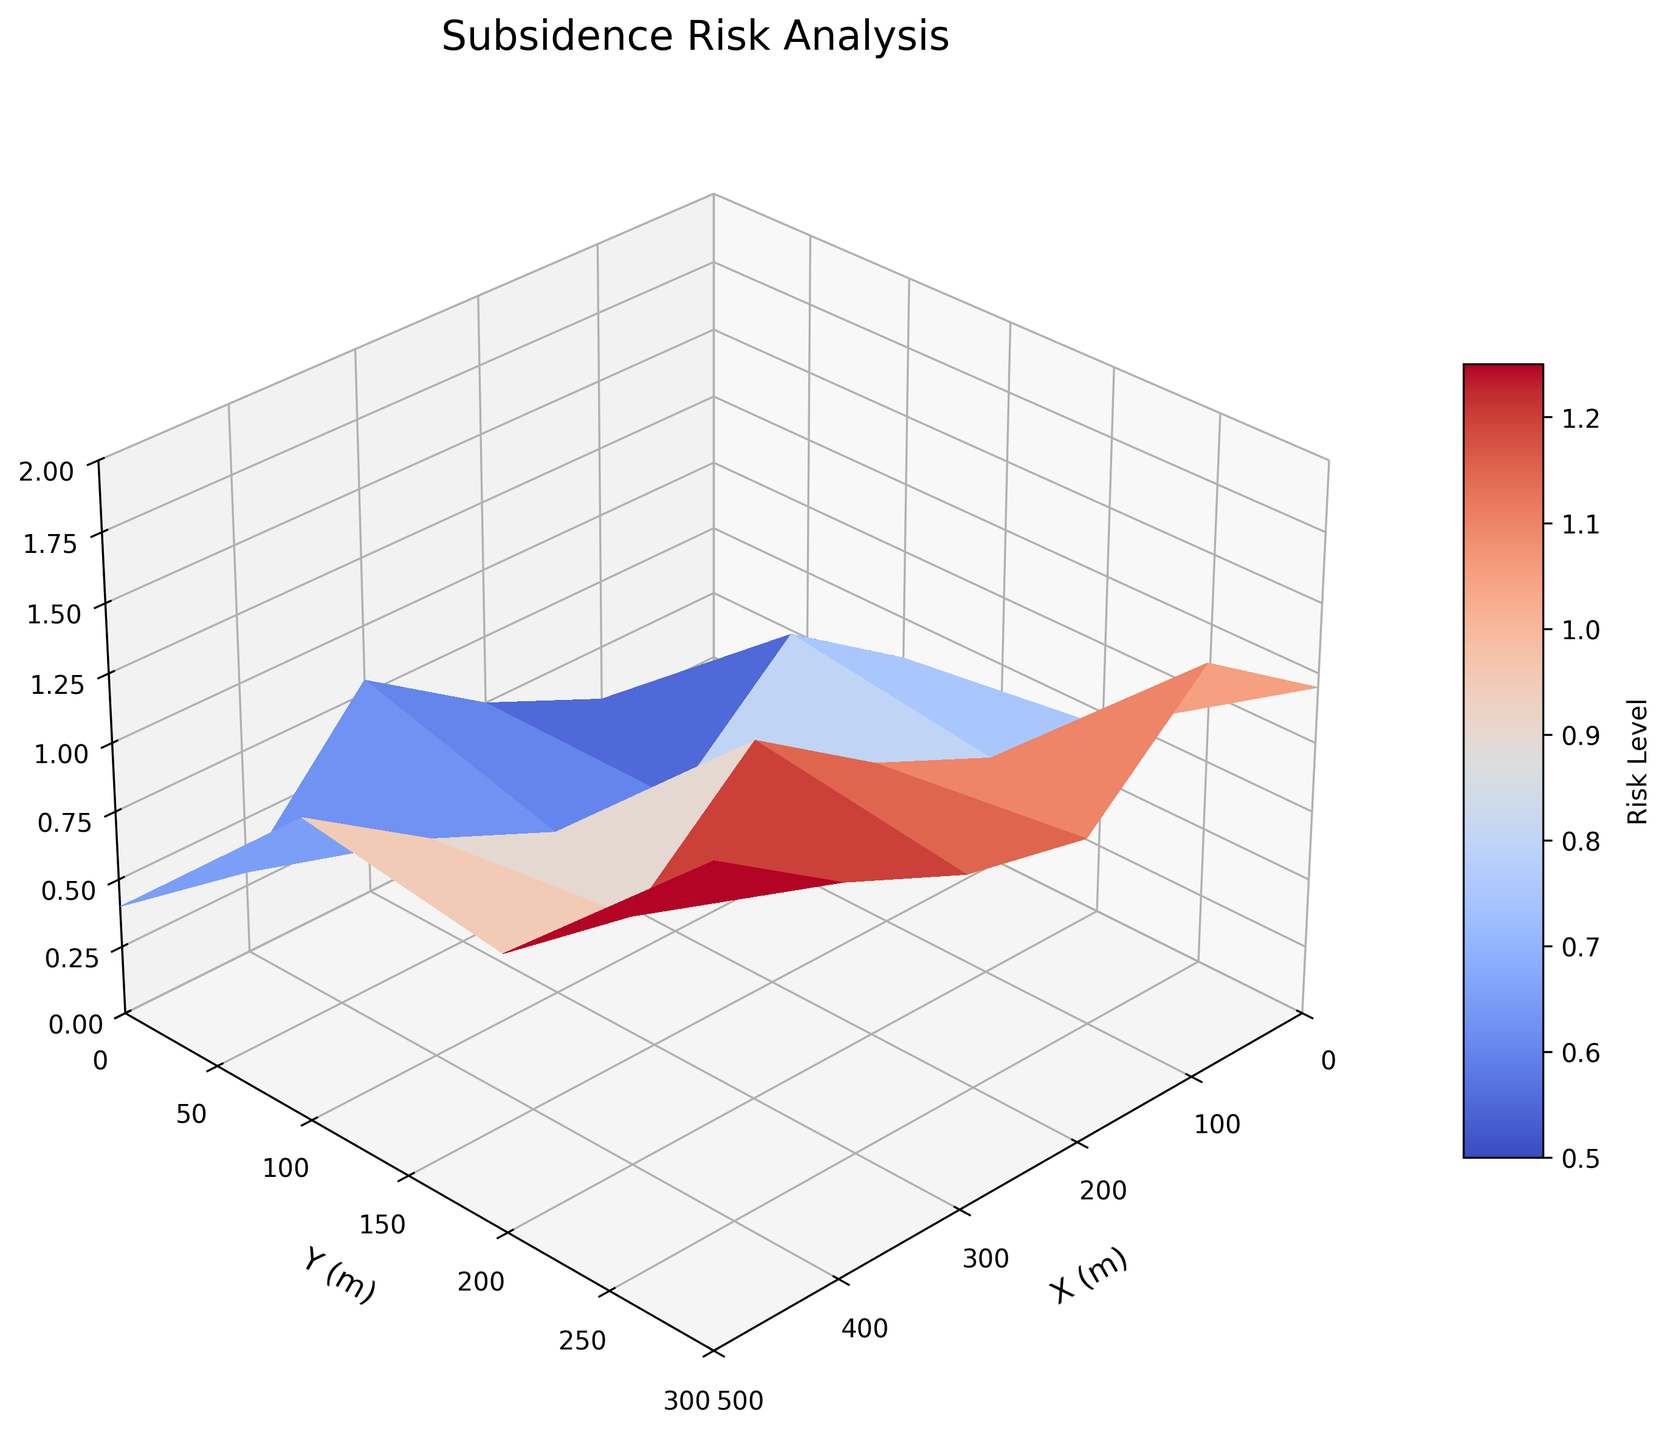What does the z-axis represent in the plot? The z-axis has a label "Subsidence Risk", indicating that it represents the risk level of subsidence.
Answer: Subsidence Risk What is the maximum subsidence risk depicted in the figure? The z-axis has a range from 0 to 2, and the highest point of the surface plot shows a value of 1.7.
Answer: 1.7 Between which values on the x-axis does the highest risk of subsidence occur? Observing the contour of the surface, the highest risk area is found where the x-values are around 500 and Y-values around 300.
Answer: 500 How does the subsidence risk vary with respect to the x-axis? As the x-value increases, the subsidence risk also increases. Initially starting from 0.2 (at x=0) and reaching the highest point of 1.7 at x=500.
Answer: It increases with increasing x In which region (x and y) is the subsidence risk minimal? The minimal subsidence risk appears to be at the coordinates where x=0 and y=0, where the risk level is 0.2.
Answer: (0, 0) Compare the subsidence risk at (x=200, y=100) and (x=400, y=200). Which one is higher? At (x=200, y=100), the subsidence risk is 0.6. At (x=400, y=200), the risk is 1.2. Therefore, the risk at (x=400, y=200) is higher.
Answer: (x=400, y=200) What is the range of subsidence risks in the figure? The risk ranges from a minimum of 0.2 to a maximum of 1.7 as indicated by the surface plot and confirmed by the z-axis limits.
Answer: 0.2 to 1.7 How is the color gradient used in the plot? The color gradient transitions from cool colors (lower risk levels) to warm colors (higher risk levels), which matches the colormap 'coolwarm'.
Answer: Cool to warm colors Is there a specific region where the risk increases less significantly along the y-axis? Along the x-axis at constant values like 0, the subsidence risk increases less significantly from y=0 to y=300 (0.2 to 0.8).
Answer: Yes, typically at lower x values Which area (segments of x and y) indicates the highest rate of increase in subsidence risk? Observing the steeper slopes, the risk increases most rapidly near higher x-values (from 400 to 500) and across y-values (from 200 to 300).
Answer: Higher segments of x (400 to 500) and y (200 to 300) 